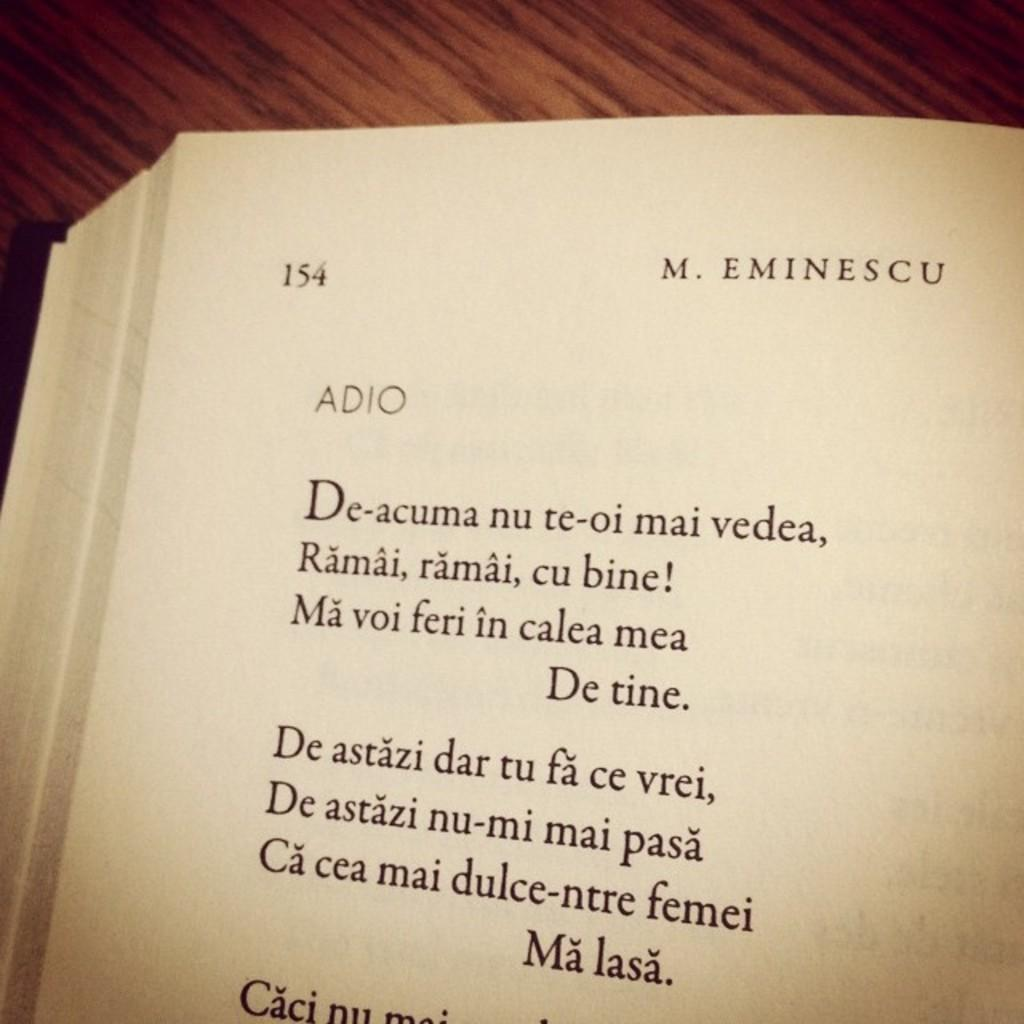What is the main subject of the image? There is a book in the center of the image. What can be found on the pages of the book? The book has text and numbers on its paper. What type of furniture is visible in the background of the image? There appears to be a table in the background of the image. How many bananas are being copied on the table in the image? There are no bananas present in the image, and therefore no copying is taking place. 